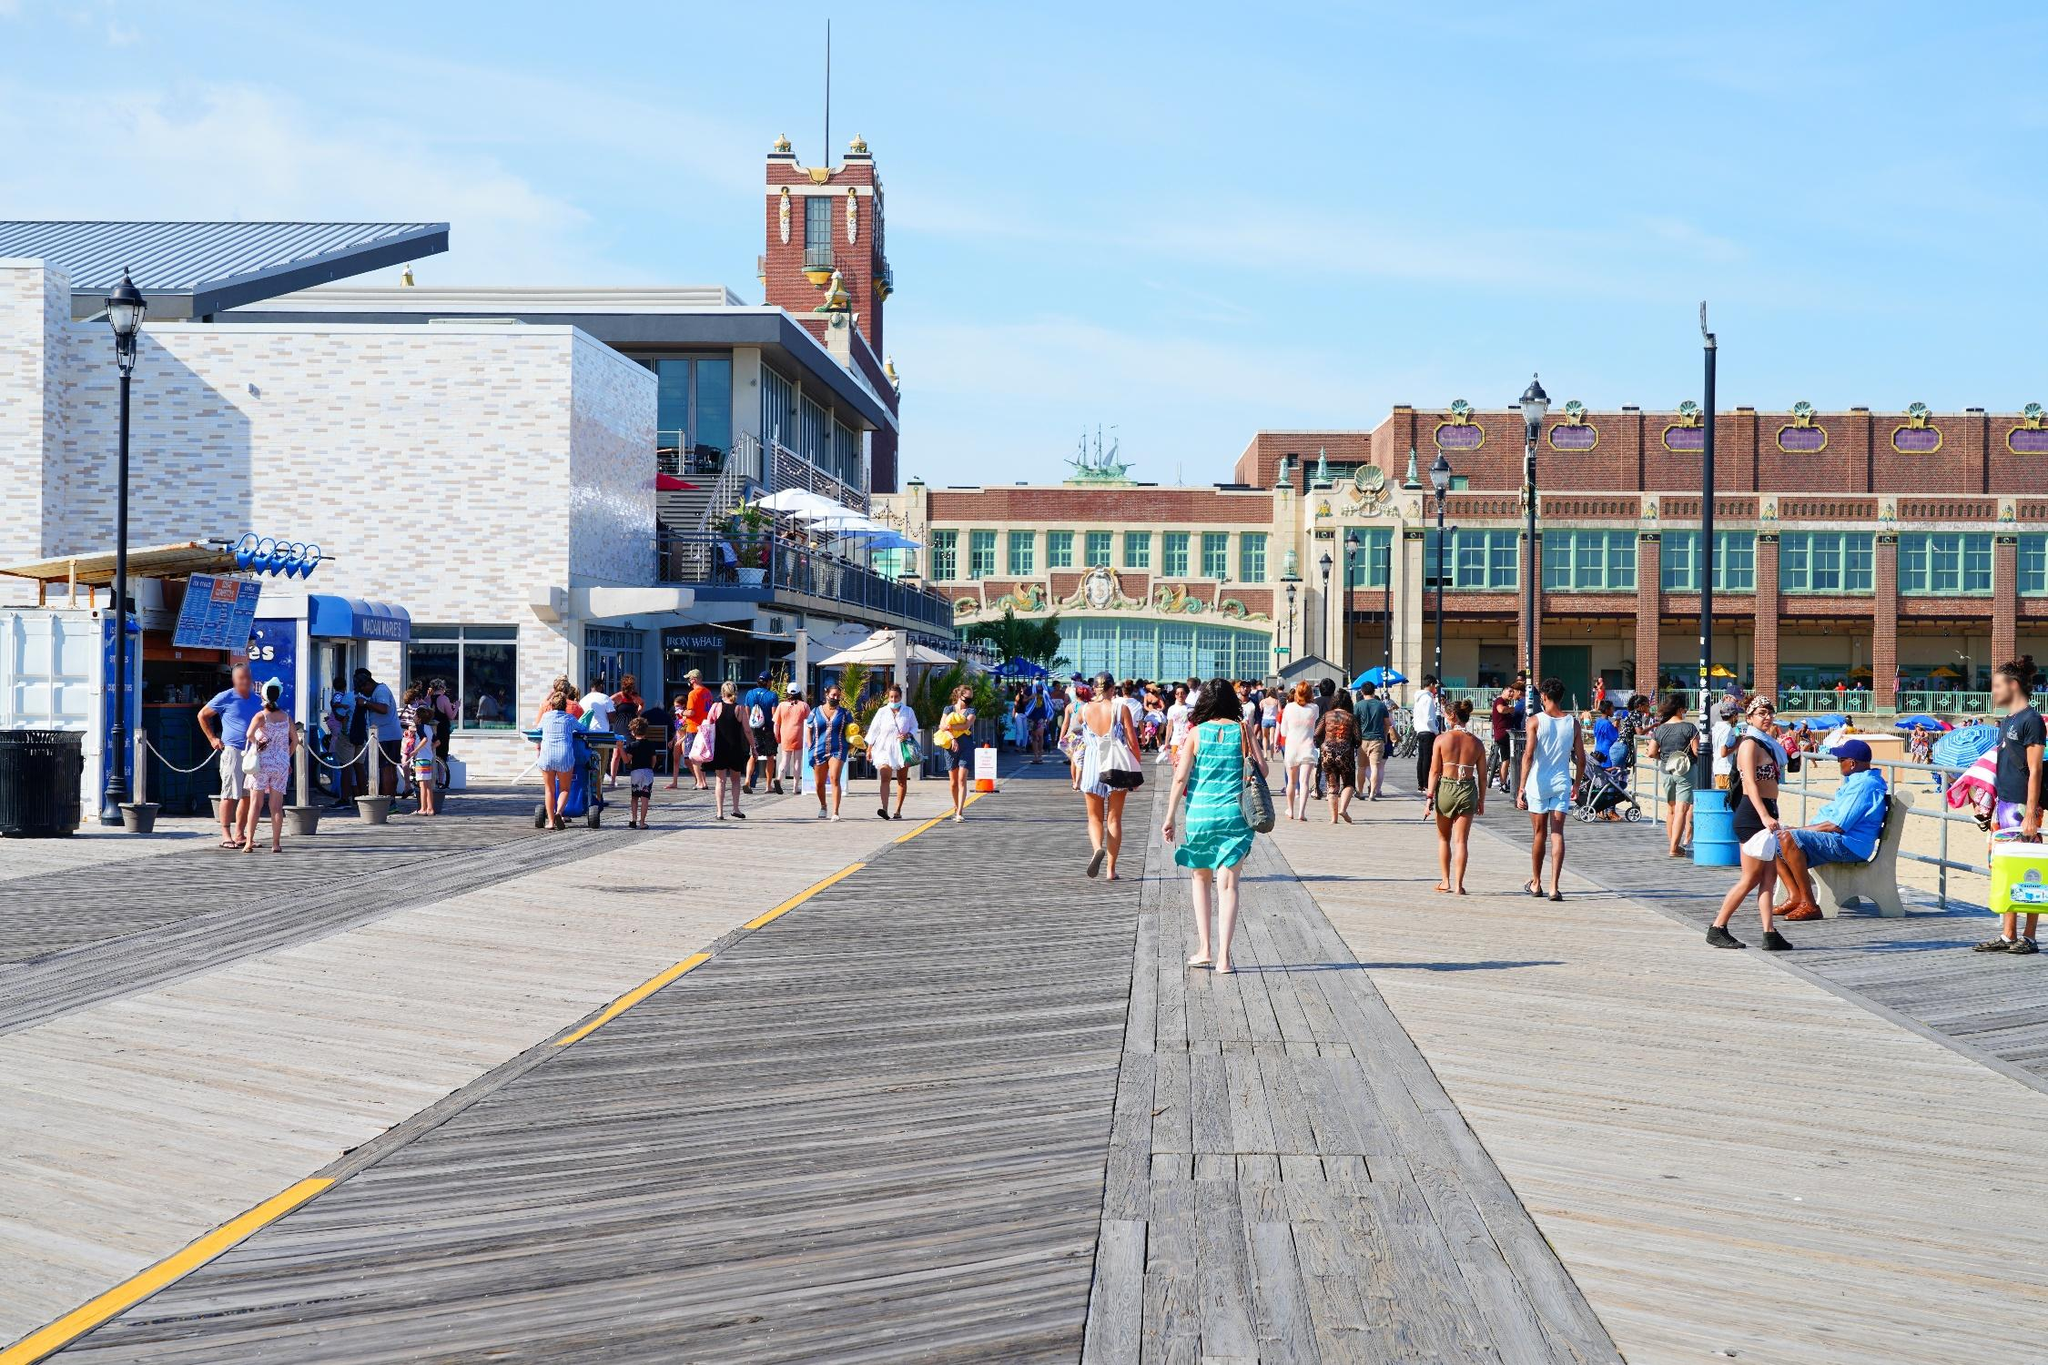What kind of food might people be getting from the food stand? The food stand likely offers a variety of quick and tasty options perfect for enjoying by the seaside. Customers might be purchasing classic boardwalk snacks such as hot dogs, soft pretzels, and fries. Ice cream cones and frozen treats could be popular choices on a warm sunny day. They might also be getting refreshing beverages like lemonade, iced tea, or smoothies. The casual and relaxed atmosphere suggests that the food is convenient and designed to be enjoyed on the go. Based on the clothing of the people, what can you infer about the season? Based on the light and casual clothing worn by the people in the image, it can be inferred that the season is likely summer. Many individuals are dressed in shorts, t-shirts, and tank tops, which are typical for warm weather. The clear blue sky and bright sunlight further reinforce the likelihood of it being a summer day, as people seem comfortable and relaxed in their attire. What if this boardwalk was transported to a city in a land of dragons and magic? How would it change? In a fantastical city of dragons and magic, the boardwalk would take on an enchanting transformation. The wooden planks might glow with runes etched by ancient wizards, guiding visitors with a soft, mystical light. The shops and eateries could become exotic kiosks selling potions, enchanted artifacts, and dragon-friendly treats. Restaurants might feature magical dishes that change flavor with each bite or provide brief glimpses into other realms. The skies above could be filled with dragons gracefully flying, occasionally stopping by to interact with the people below.

The clock tower would become an arcane beacon, its hands not only telling time but also pointing to different dimensions or magical occurrences. Enchanted lampposts lining the boardwalk might flicker with different colors, reacting to the ambient magic in the air. Street performers would likely be sorcerers and illusionists, captivating audiences with their spells and enigmatic performances. Despite these fantastical changes, the boardwalk would remain a lively center of activity, retaining its charm and the essence of human and dragon camaraderie. 